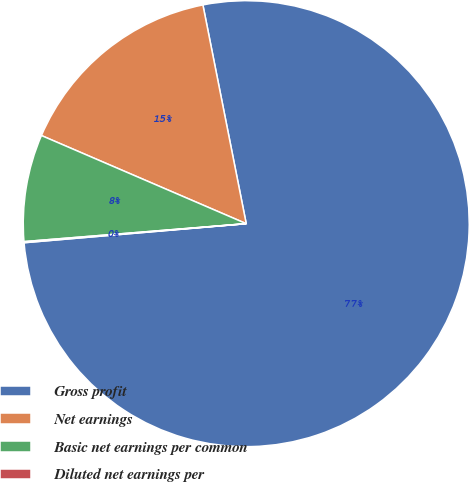<chart> <loc_0><loc_0><loc_500><loc_500><pie_chart><fcel>Gross profit<fcel>Net earnings<fcel>Basic net earnings per common<fcel>Diluted net earnings per<nl><fcel>76.75%<fcel>15.42%<fcel>7.75%<fcel>0.08%<nl></chart> 